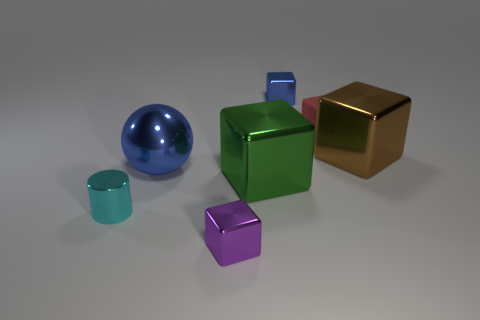Subtract 1 cubes. How many cubes are left? 4 Subtract all brown shiny cubes. How many cubes are left? 4 Subtract all blue cubes. How many cubes are left? 4 Subtract all cyan cubes. Subtract all yellow spheres. How many cubes are left? 5 Add 3 small yellow spheres. How many objects exist? 10 Subtract all cylinders. How many objects are left? 6 Add 1 purple objects. How many purple objects exist? 2 Subtract 1 blue balls. How many objects are left? 6 Subtract all red rubber things. Subtract all red matte cubes. How many objects are left? 5 Add 3 blue metal things. How many blue metal things are left? 5 